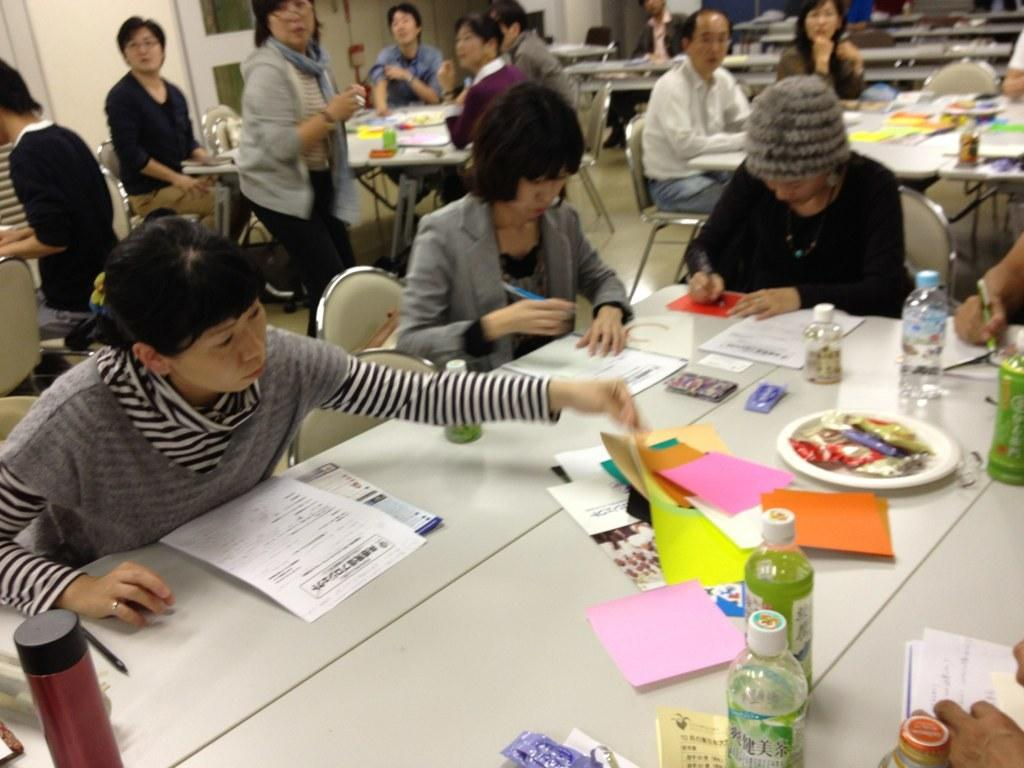How many people are in the image? There are people in the image, but the exact number is not specified. What are the people doing in the image? The people are sitting on chairs in the image. What objects can be seen on the tables in the image? There are bottles, papers, and books on the tables in the image. What type of sign can be seen in the image? There is no sign present in the image. How many geese are visible in the image? There are no geese present in the image. 